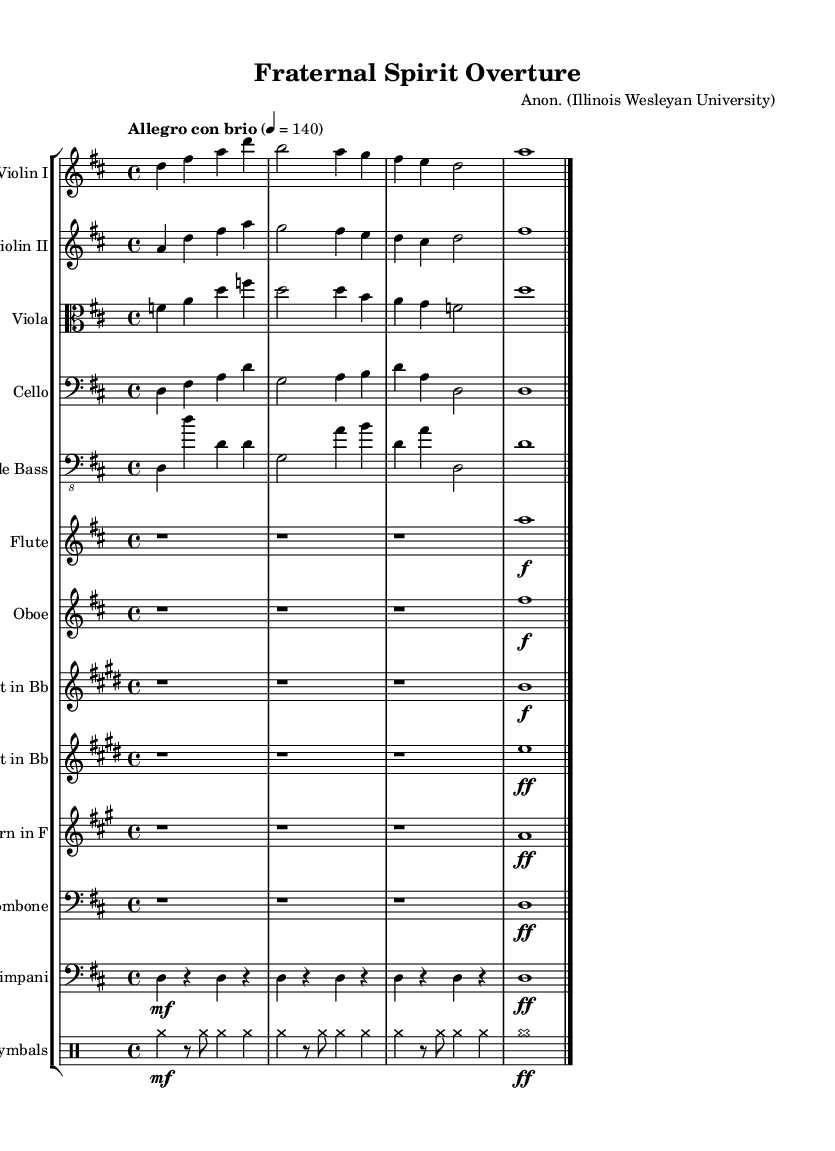What is the key signature of this music? The key signature is D major, which has two sharps: F# and C#.
Answer: D major What is the time signature of this piece? The time signature is 4/4, indicating four beats per measure.
Answer: 4/4 What is the tempo marking given for this music? The tempo marking is "Allegro con brio", indicating a lively and spirited tempo.
Answer: Allegro con brio How many measures are in the Violin I part? There are four measures in the Violin I part, as indicated by the grouped notes and bars.
Answer: 4 Explain the difference in instrumentation between the Violin and Viola parts. The Violin parts are written in the treble clef and play higher pitch notes, while the Viola part is in the alto clef, indicating lower pitch notes. This difference delineates the ranges of the instruments and their roles in the harmony.
Answer: Violin: treble clef; Viola: alto clef What is the dynamic marking for the Flute part? The dynamic marking for the Flute part is marked with a "f", indicating it should be played loudly or with force.
Answer: f What type of ensemble is this music written for? This music is written for a symphony orchestra, as it includes a variety of instruments typical of orchestral arrangements.
Answer: Symphony orchestra 